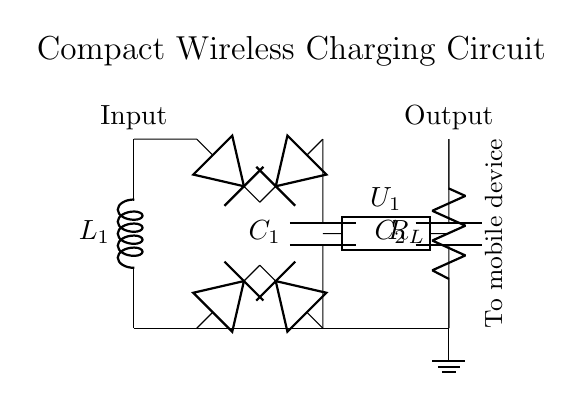What type of inductor is used in the circuit? The circuit includes a single inductor represented as L1, which indicates that it is used for wireless energy transmission.
Answer: Inductor What components are used for rectification? The circuit uses a bridge rectifier made up of four diodes. This configuration allows conversion of alternating current generated by the wireless coil into direct current.
Answer: Diodes What is the purpose of capacitor C1? Capacitor C1 smooths the output voltage by filtering out the ripples from the rectified signal, ensuring a stable DC supply to the next stages of the circuit.
Answer: Smoothing How many capacitors are present in the circuit? There are two capacitors in the circuit: C1 for smoothing and C2 for output stabilization.
Answer: Two What does the symbol U1 represent in the circuit? The symbol U1 indicates a voltage regulator, which is responsible for maintaining a constant output voltage regardless of the load current or input voltage fluctuations.
Answer: Voltage regulator What is the intended load for this circuit? The load represented as R_L is a mobile device, which indicates that the circuit is designed to provide power to such devices wirelessly.
Answer: Mobile device Is this circuit for AC or DC power? The circuit converts AC power from the wireless coil into DC power through the rectifier, hence the output is in DC form.
Answer: DC 